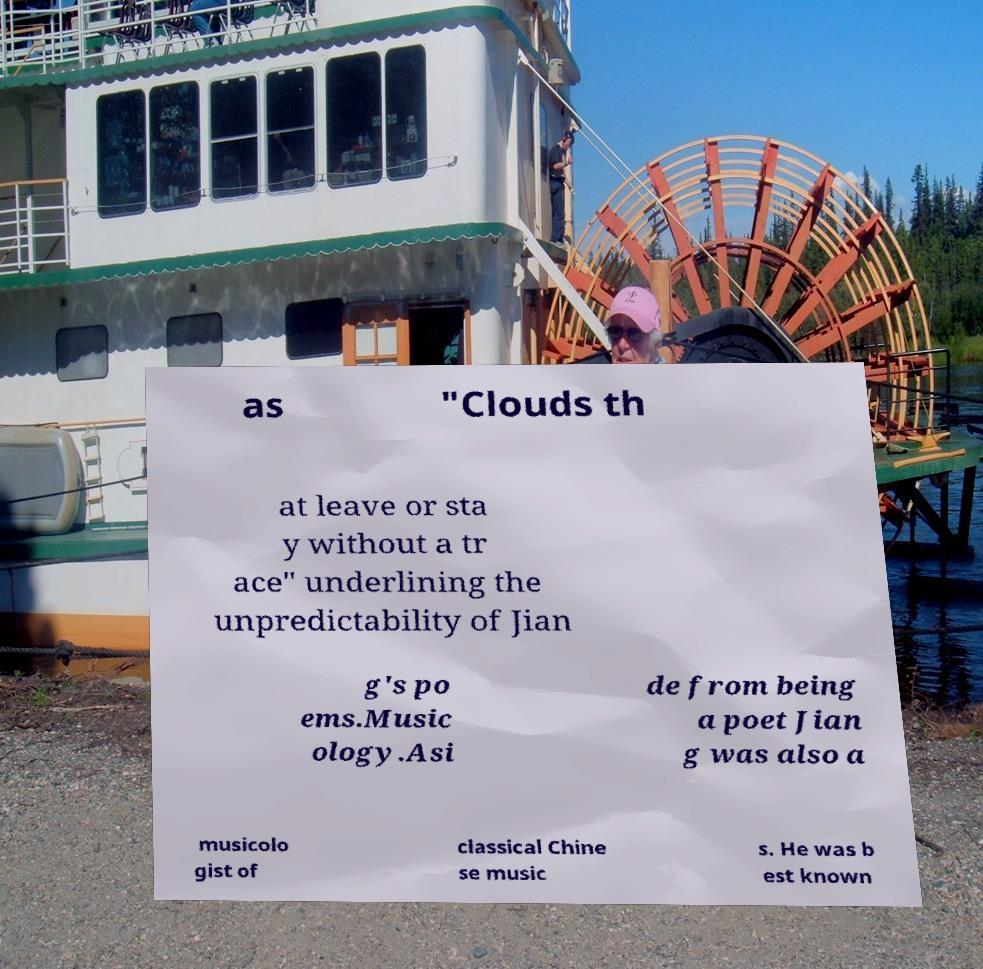For documentation purposes, I need the text within this image transcribed. Could you provide that? as "Clouds th at leave or sta y without a tr ace" underlining the unpredictability of Jian g's po ems.Music ology.Asi de from being a poet Jian g was also a musicolo gist of classical Chine se music s. He was b est known 